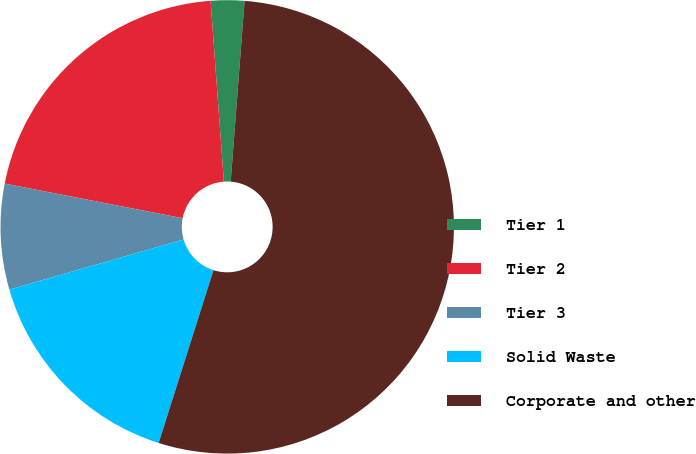Convert chart. <chart><loc_0><loc_0><loc_500><loc_500><pie_chart><fcel>Tier 1<fcel>Tier 2<fcel>Tier 3<fcel>Solid Waste<fcel>Corporate and other<nl><fcel>2.39%<fcel>20.77%<fcel>7.52%<fcel>15.65%<fcel>53.67%<nl></chart> 